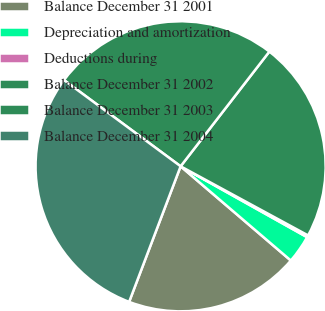Convert chart to OTSL. <chart><loc_0><loc_0><loc_500><loc_500><pie_chart><fcel>Balance December 31 2001<fcel>Depreciation and amortization<fcel>Deductions during<fcel>Balance December 31 2002<fcel>Balance December 31 2003<fcel>Balance December 31 2004<nl><fcel>19.52%<fcel>3.13%<fcel>0.22%<fcel>22.43%<fcel>25.35%<fcel>29.36%<nl></chart> 